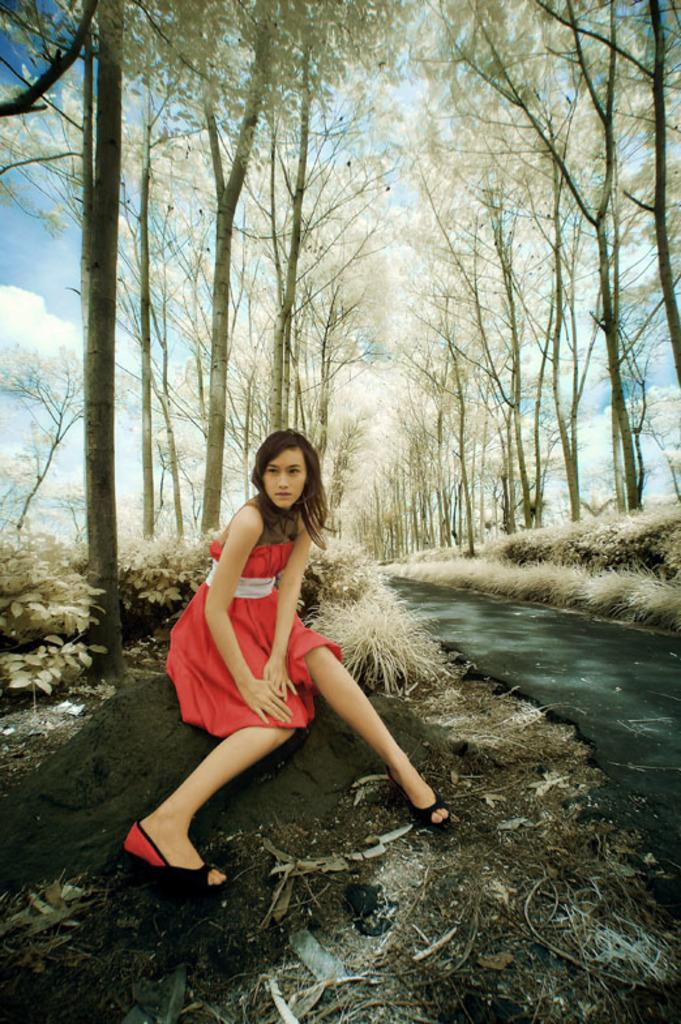What is the woman in the image doing? The woman is sitting on a rock in the image. What can be seen in the background of the image? The sky is visible in the background of the image. What type of vegetation is present in the image? There are plants, grass, and trees in the image. What type of surface is visible in the image? There is a road in the image. What type of ink is being used by the woman in the image? There is no ink or writing activity present in the image; the woman is simply sitting on a rock. 